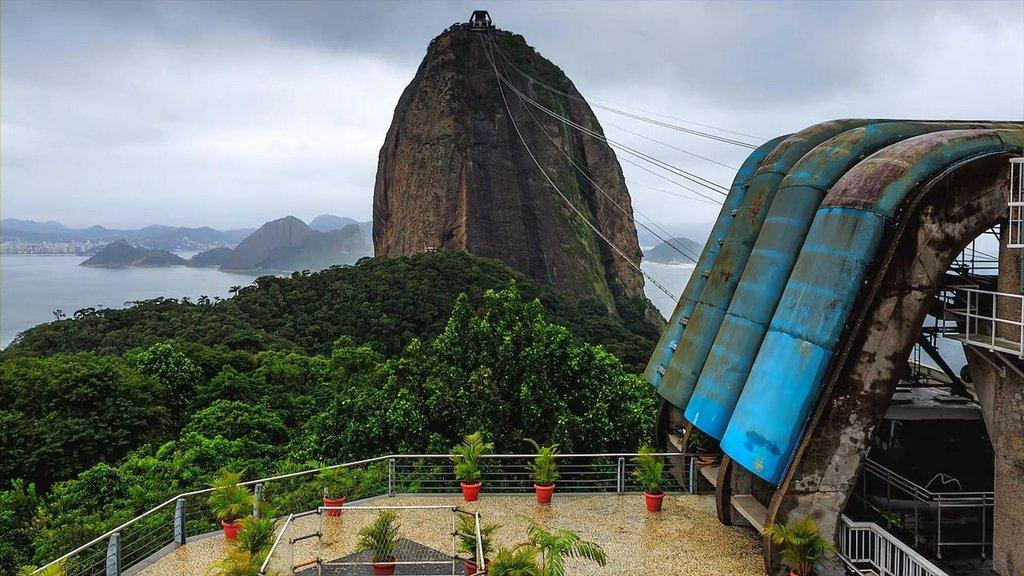Please provide a concise description of this image. In this image we can see a rock, here are the wires, there are the trees, here are the flower pots, there is the water, there are the mountains, at above here is the sky. 